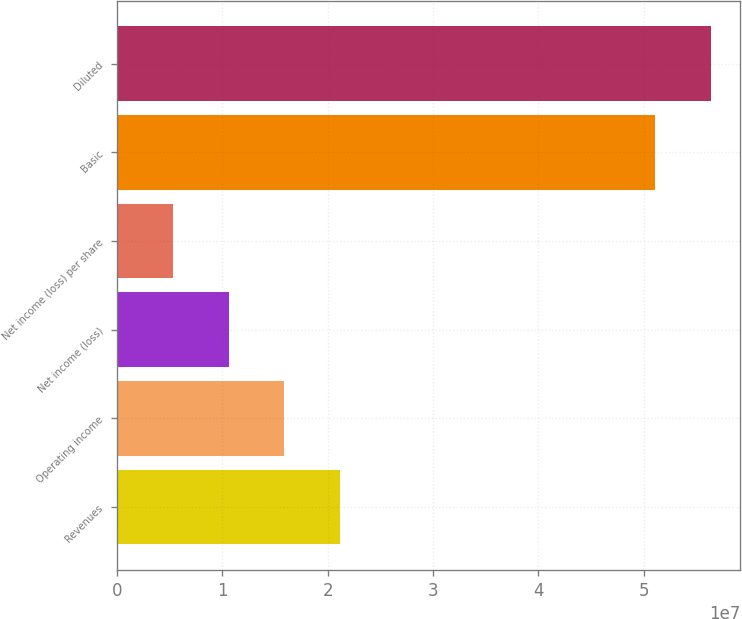<chart> <loc_0><loc_0><loc_500><loc_500><bar_chart><fcel>Revenues<fcel>Operating income<fcel>Net income (loss)<fcel>Net income (loss) per share<fcel>Basic<fcel>Diluted<nl><fcel>2.11912e+07<fcel>1.58934e+07<fcel>1.05956e+07<fcel>5.29781e+06<fcel>5.10565e+07<fcel>5.63543e+07<nl></chart> 